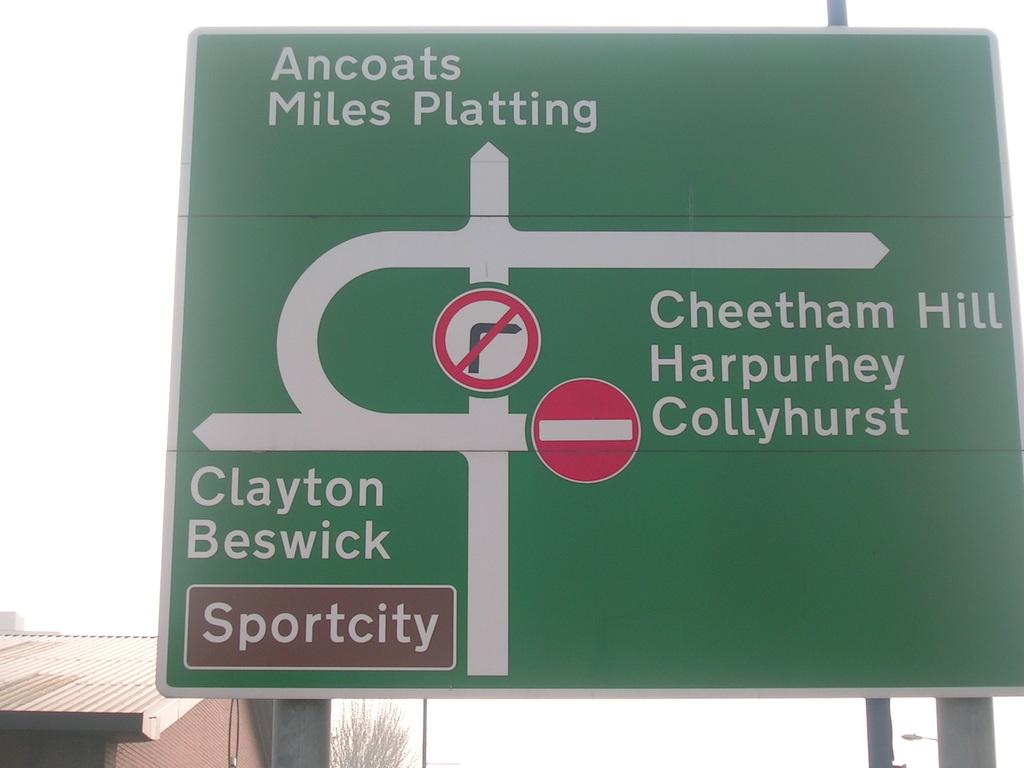<image>
Give a short and clear explanation of the subsequent image. According to this street sign, if you proceed straight, you will head toward Ancoats and Miles Platting. 